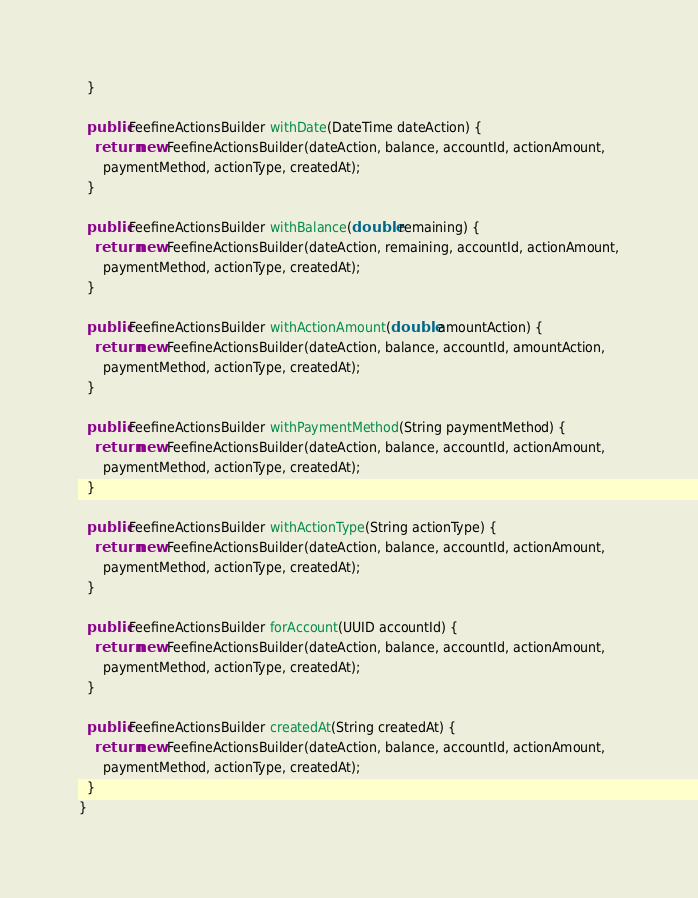<code> <loc_0><loc_0><loc_500><loc_500><_Java_>  }

  public FeefineActionsBuilder withDate(DateTime dateAction) {
    return new FeefineActionsBuilder(dateAction, balance, accountId, actionAmount,
      paymentMethod, actionType, createdAt);
  }

  public FeefineActionsBuilder withBalance(double remaining) {
    return new FeefineActionsBuilder(dateAction, remaining, accountId, actionAmount,
      paymentMethod, actionType, createdAt);
  }

  public FeefineActionsBuilder withActionAmount(double amountAction) {
    return new FeefineActionsBuilder(dateAction, balance, accountId, amountAction,
      paymentMethod, actionType, createdAt);
  }

  public FeefineActionsBuilder withPaymentMethod(String paymentMethod) {
    return new FeefineActionsBuilder(dateAction, balance, accountId, actionAmount,
      paymentMethod, actionType, createdAt);
  }

  public FeefineActionsBuilder withActionType(String actionType) {
    return new FeefineActionsBuilder(dateAction, balance, accountId, actionAmount,
      paymentMethod, actionType, createdAt);
  }

  public FeefineActionsBuilder forAccount(UUID accountId) {
    return new FeefineActionsBuilder(dateAction, balance, accountId, actionAmount,
      paymentMethod, actionType, createdAt);
  }

  public FeefineActionsBuilder createdAt(String createdAt) {
    return new FeefineActionsBuilder(dateAction, balance, accountId, actionAmount,
      paymentMethod, actionType, createdAt);
  }
}
</code> 